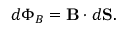<formula> <loc_0><loc_0><loc_500><loc_500>d \Phi _ { B } = B \cdot d S .</formula> 